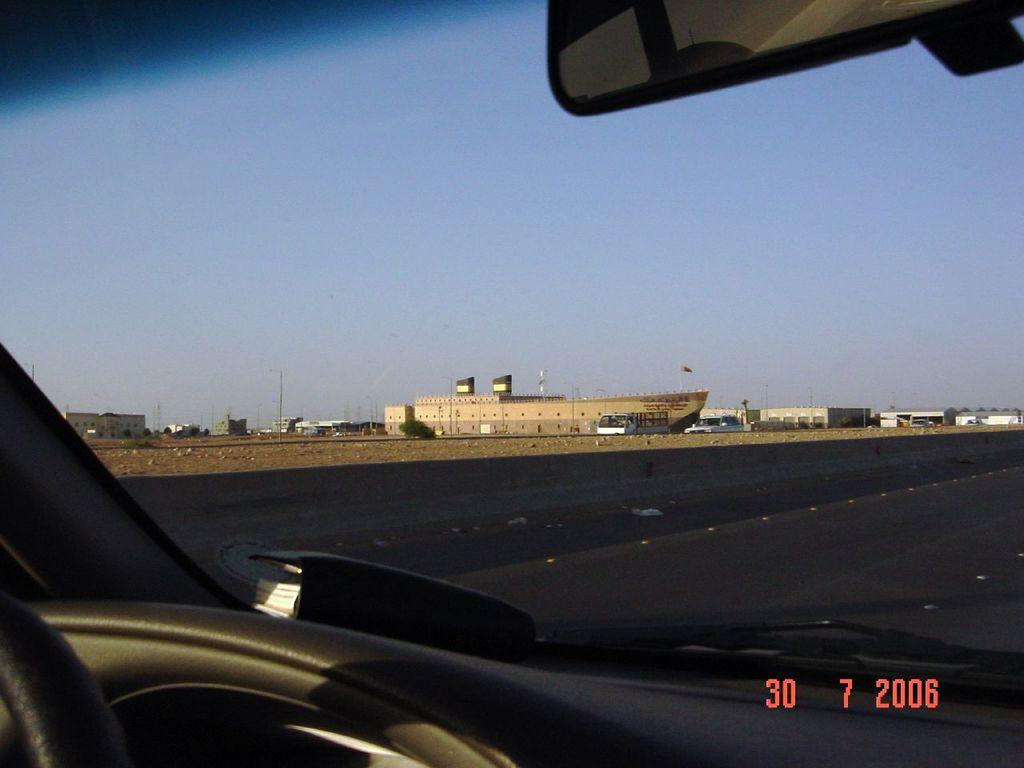What type of view does the image provide? The image is an inside view of a car. What can be seen outside the car through the window glass? Buildings, poles, and the sky are visible through the window glass of the car. How many sisters are sitting in the car in the image? There are no sisters present in the image; it is an inside view of a car with no visible people. What type of taste can be experienced from the image? There is no taste associated with the image, as it is a visual representation of the inside of a car. 